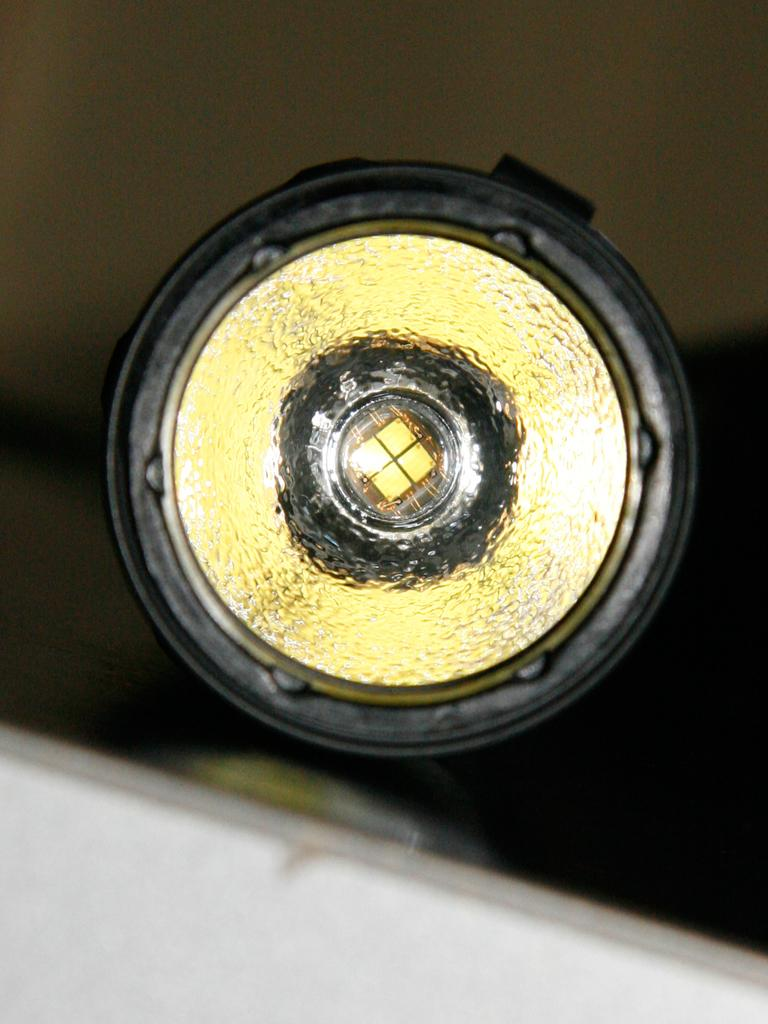What can be seen in the image that provides illumination? There is a light in the image. What is the appearance of the background in the image? The background of the image is blurred. What type of square object can be seen playing songs in the image? There is no square object playing songs in the image; the facts provided do not mention any such object. 